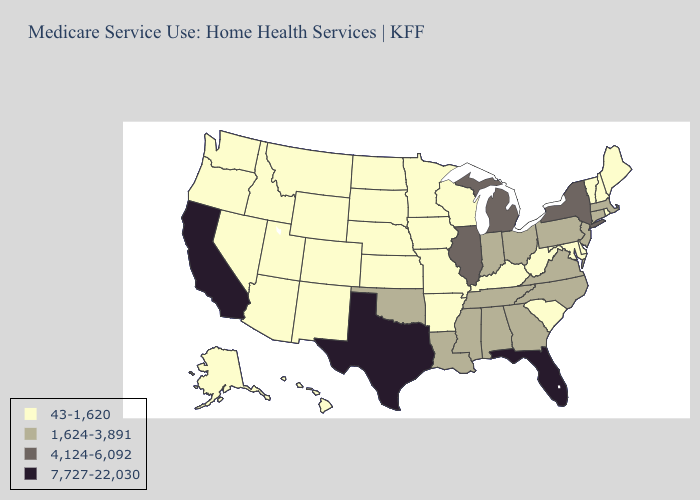What is the highest value in the USA?
Quick response, please. 7,727-22,030. Among the states that border Michigan , does Indiana have the lowest value?
Quick response, please. No. Among the states that border Tennessee , which have the lowest value?
Quick response, please. Arkansas, Kentucky, Missouri. Which states have the lowest value in the Northeast?
Give a very brief answer. Maine, New Hampshire, Rhode Island, Vermont. What is the highest value in states that border Delaware?
Short answer required. 1,624-3,891. Name the states that have a value in the range 7,727-22,030?
Keep it brief. California, Florida, Texas. Name the states that have a value in the range 43-1,620?
Give a very brief answer. Alaska, Arizona, Arkansas, Colorado, Delaware, Hawaii, Idaho, Iowa, Kansas, Kentucky, Maine, Maryland, Minnesota, Missouri, Montana, Nebraska, Nevada, New Hampshire, New Mexico, North Dakota, Oregon, Rhode Island, South Carolina, South Dakota, Utah, Vermont, Washington, West Virginia, Wisconsin, Wyoming. Name the states that have a value in the range 4,124-6,092?
Answer briefly. Illinois, Michigan, New York. Does Texas have the same value as Florida?
Answer briefly. Yes. Which states have the lowest value in the USA?
Quick response, please. Alaska, Arizona, Arkansas, Colorado, Delaware, Hawaii, Idaho, Iowa, Kansas, Kentucky, Maine, Maryland, Minnesota, Missouri, Montana, Nebraska, Nevada, New Hampshire, New Mexico, North Dakota, Oregon, Rhode Island, South Carolina, South Dakota, Utah, Vermont, Washington, West Virginia, Wisconsin, Wyoming. What is the highest value in states that border Minnesota?
Keep it brief. 43-1,620. What is the highest value in states that border Wyoming?
Concise answer only. 43-1,620. Which states hav the highest value in the Northeast?
Quick response, please. New York. Does Nevada have the highest value in the USA?
Answer briefly. No. 